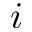Convert formula to latex. <formula><loc_0><loc_0><loc_500><loc_500>i</formula> 